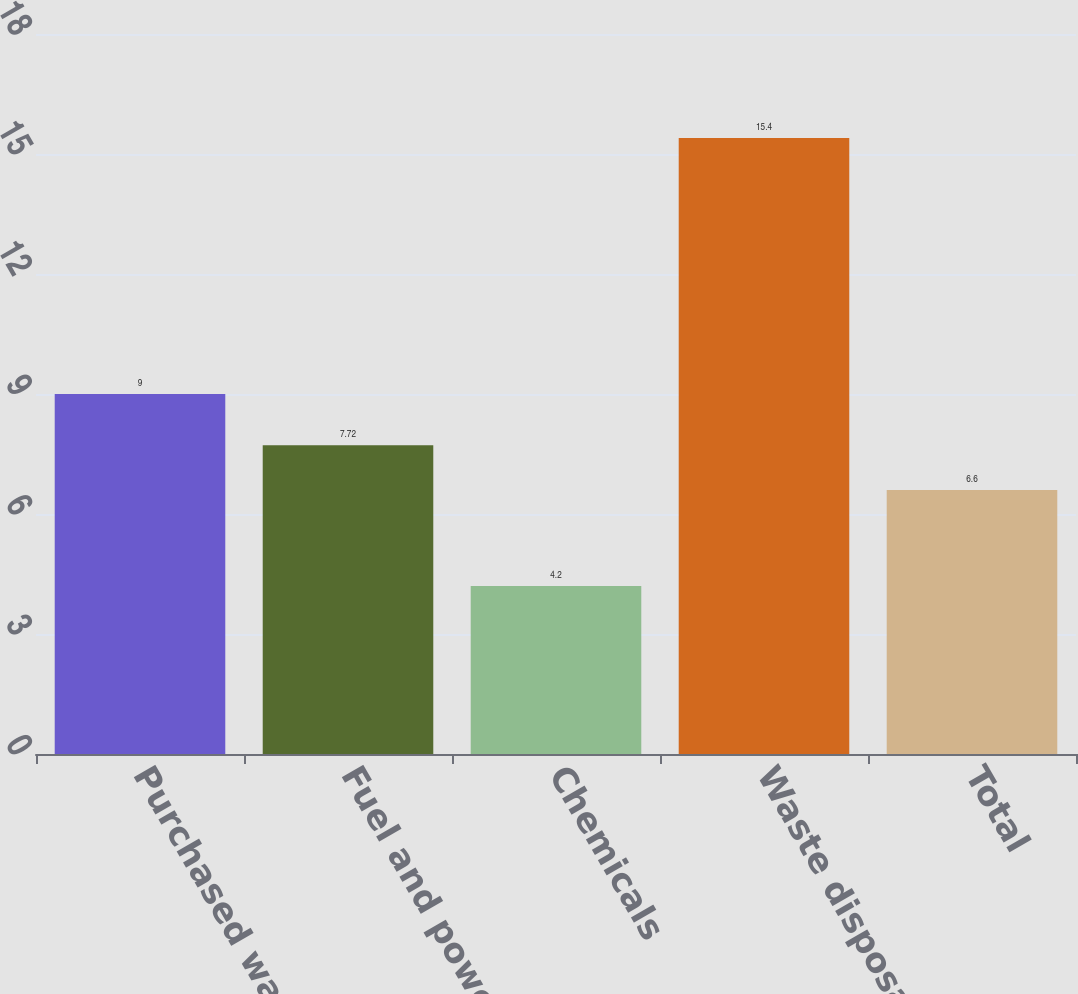<chart> <loc_0><loc_0><loc_500><loc_500><bar_chart><fcel>Purchased water<fcel>Fuel and power<fcel>Chemicals<fcel>Waste disposal<fcel>Total<nl><fcel>9<fcel>7.72<fcel>4.2<fcel>15.4<fcel>6.6<nl></chart> 